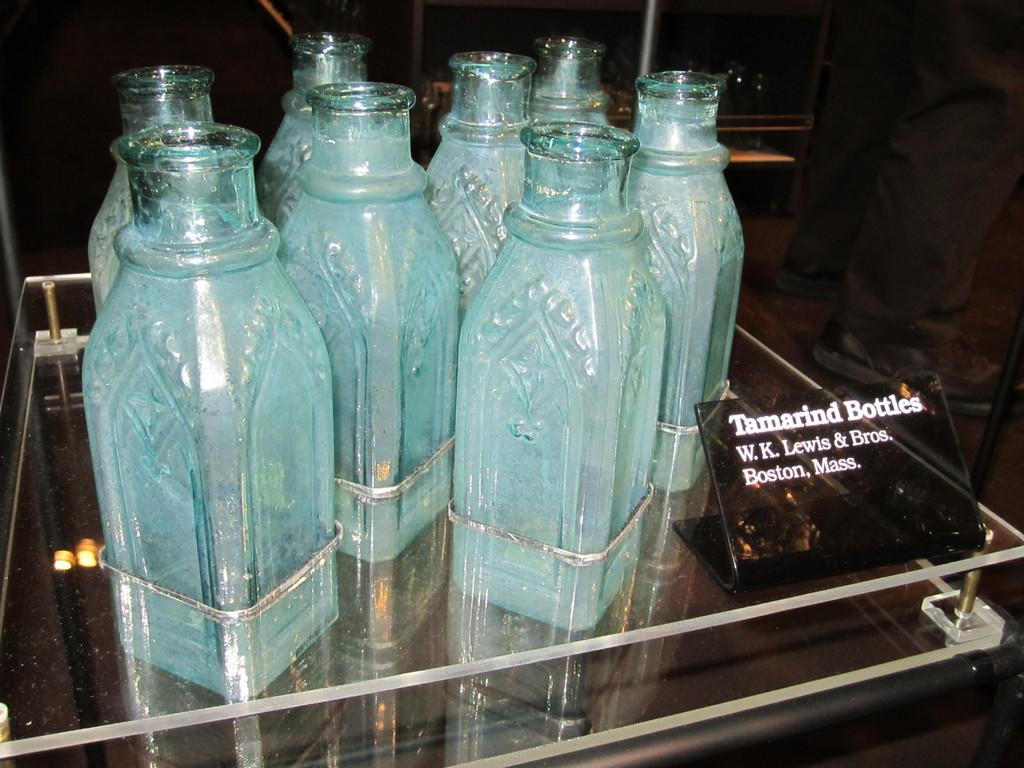<image>
Render a clear and concise summary of the photo. Eight Tamarind Bottles by W.K. Lewis and Bros is on display. 